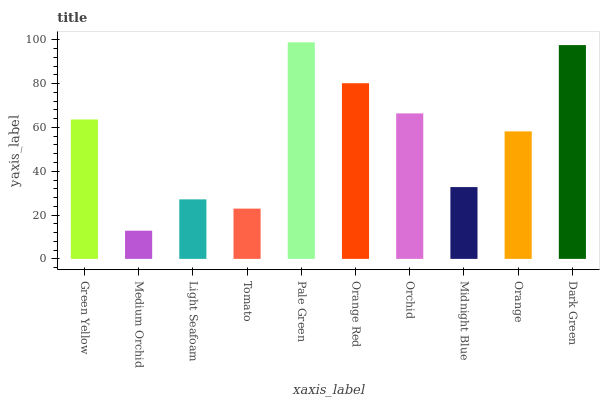Is Medium Orchid the minimum?
Answer yes or no. Yes. Is Pale Green the maximum?
Answer yes or no. Yes. Is Light Seafoam the minimum?
Answer yes or no. No. Is Light Seafoam the maximum?
Answer yes or no. No. Is Light Seafoam greater than Medium Orchid?
Answer yes or no. Yes. Is Medium Orchid less than Light Seafoam?
Answer yes or no. Yes. Is Medium Orchid greater than Light Seafoam?
Answer yes or no. No. Is Light Seafoam less than Medium Orchid?
Answer yes or no. No. Is Green Yellow the high median?
Answer yes or no. Yes. Is Orange the low median?
Answer yes or no. Yes. Is Light Seafoam the high median?
Answer yes or no. No. Is Medium Orchid the low median?
Answer yes or no. No. 